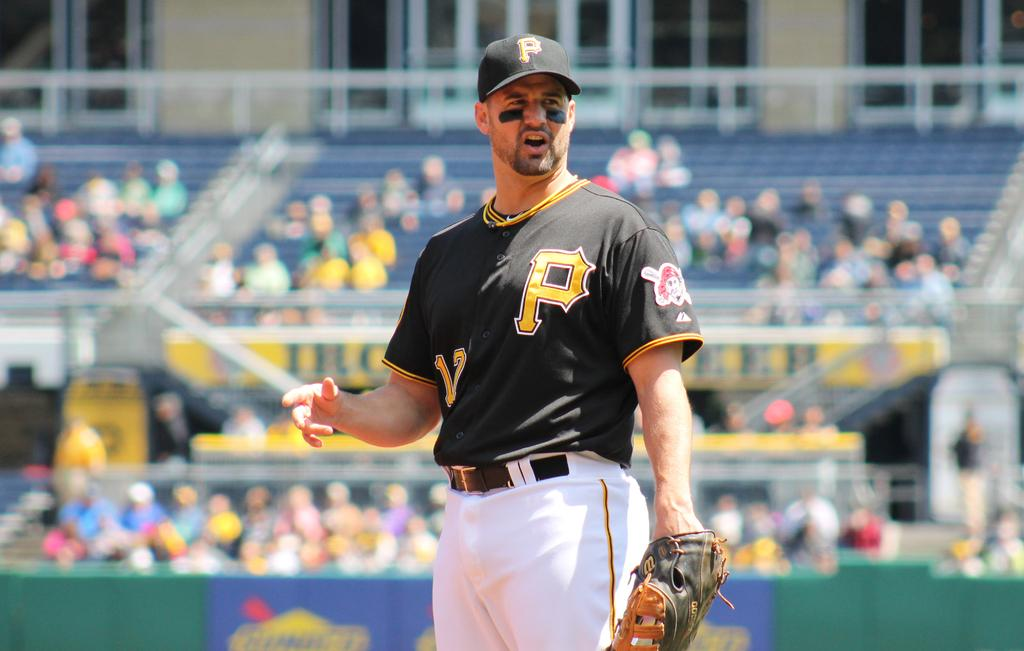Provide a one-sentence caption for the provided image. A sportsperson wearing a baseball cap and shirt, both of which have the letter P on. 